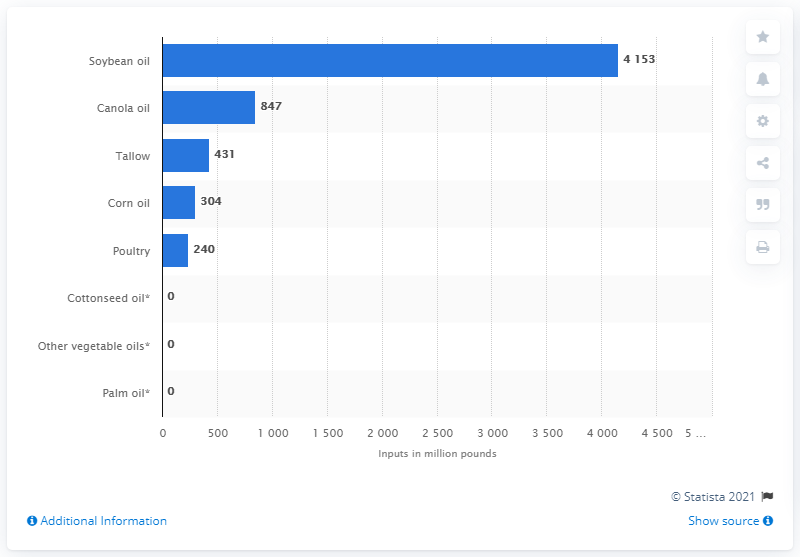Give some essential details in this illustration. In 2011, the total amount of canola oil inputs was 847. 